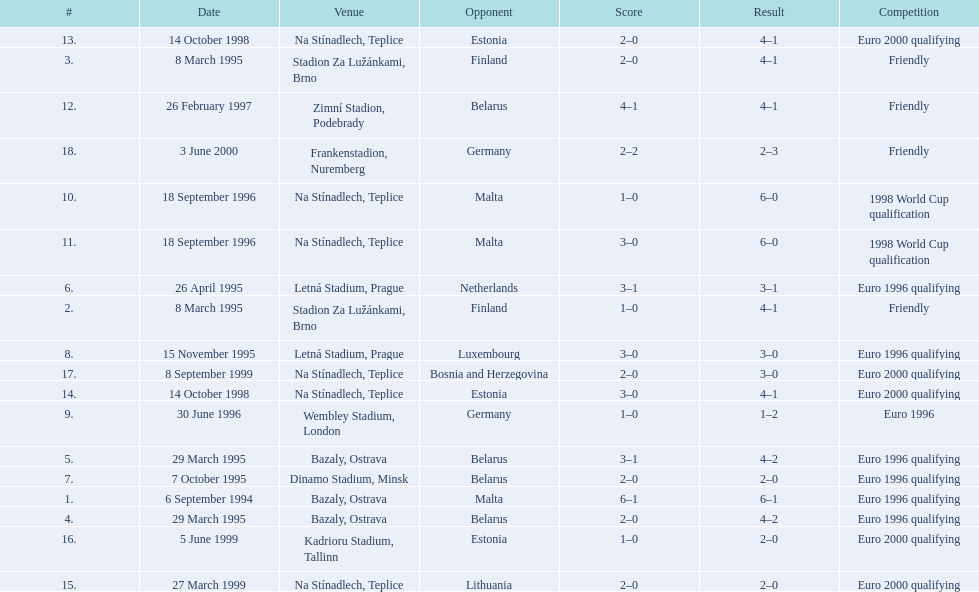What opponent is listed last on the table? Germany. 